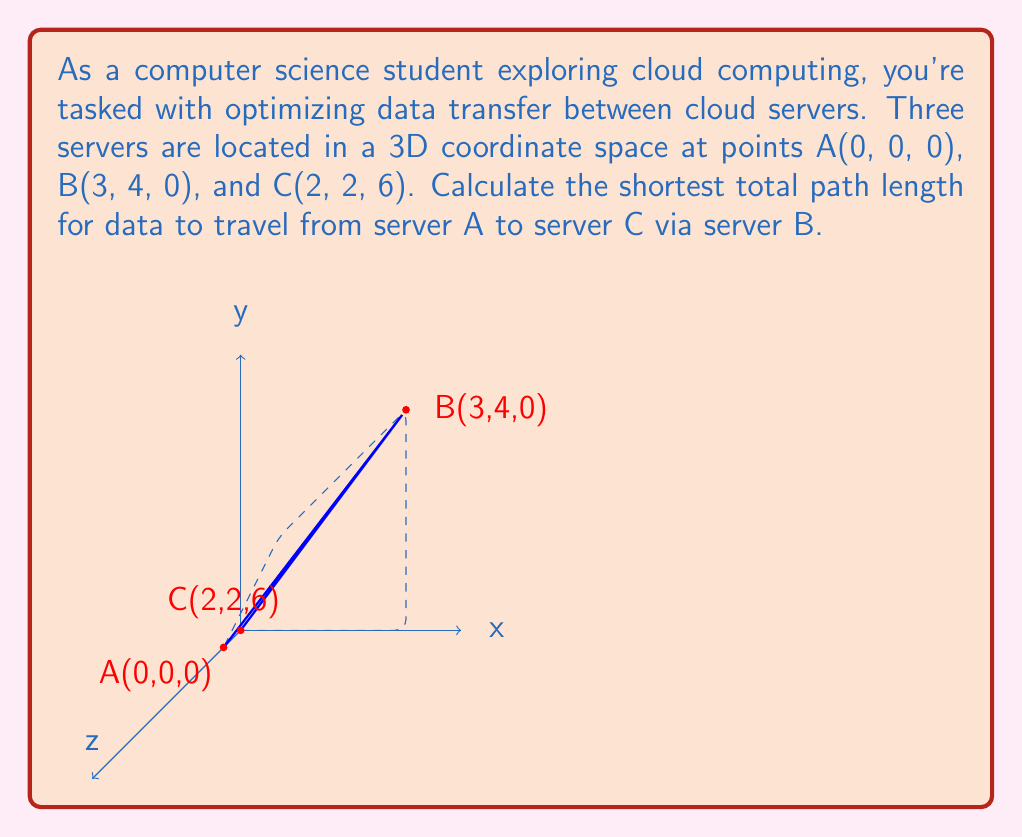Can you answer this question? To solve this problem, we need to calculate the distances AB and BC, then sum them up. We can use the distance formula in 3D space:

$$d = \sqrt{(x_2-x_1)^2 + (y_2-y_1)^2 + (z_2-z_1)^2}$$

Step 1: Calculate distance AB
$$AB = \sqrt{(3-0)^2 + (4-0)^2 + (0-0)^2}$$
$$AB = \sqrt{9 + 16 + 0} = \sqrt{25} = 5$$

Step 2: Calculate distance BC
$$BC = \sqrt{(2-3)^2 + (2-4)^2 + (6-0)^2}$$
$$BC = \sqrt{(-1)^2 + (-2)^2 + 6^2}$$
$$BC = \sqrt{1 + 4 + 36} = \sqrt{41}$$

Step 3: Sum up the total distance
Total distance = AB + BC = $5 + \sqrt{41}$
Answer: $5 + \sqrt{41}$ 